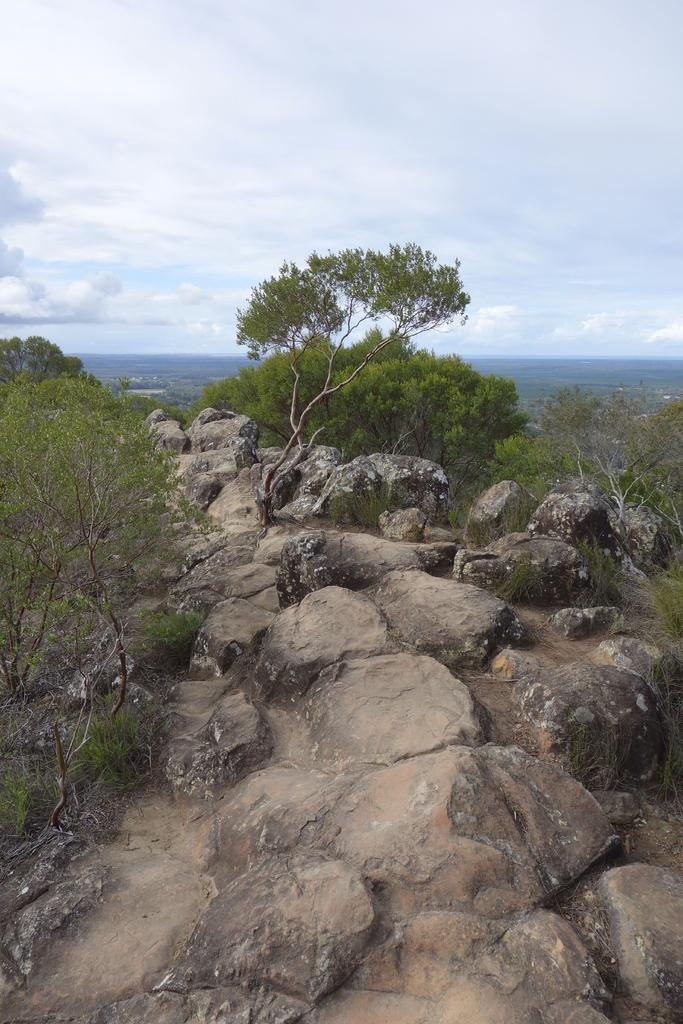What type of natural elements can be seen in the image? There are rocks and trees in the image. What is visible in the background of the image? The sky is visible in the background of the image. Are there any clouds in the sky? Yes, clouds are present in the sky. How many cars can be seen driving through the rocks in the image? There are no cars present in the image; it features rocks and trees. Can you describe the example of a bee buzzing around the trees in the image? There is no bee present in the image; it only features rocks and trees. 